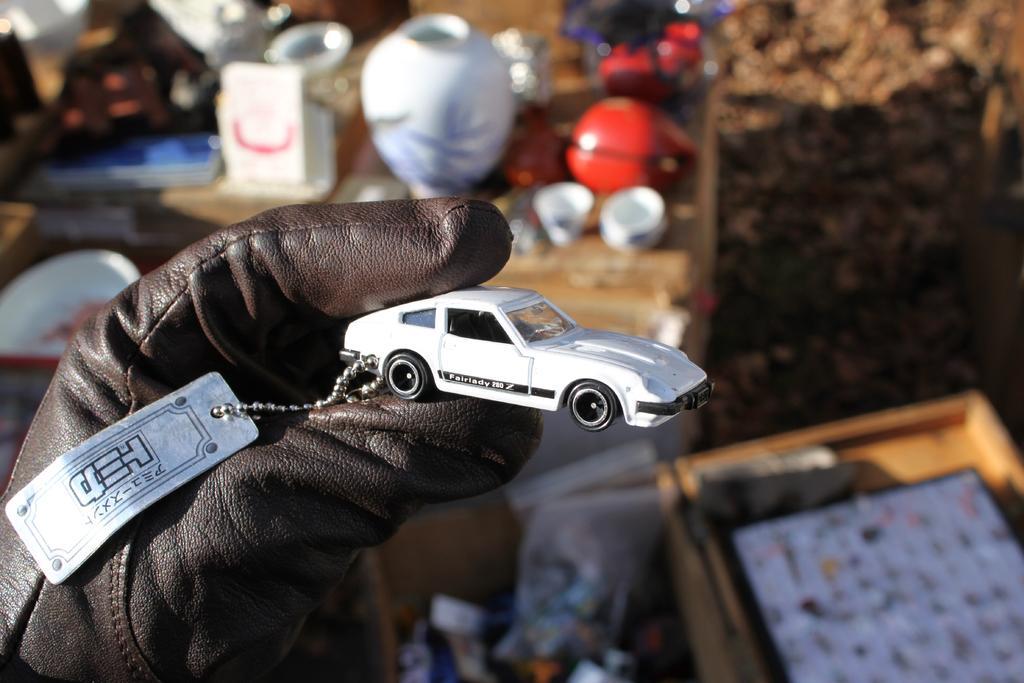In one or two sentences, can you explain what this image depicts? In the front of the image we can see a person's hand wearing a glove, holding a car and there is a steel board along with a chain. Something is written on the steel board and toy car. In the background of the image is it blur and there are objects.   